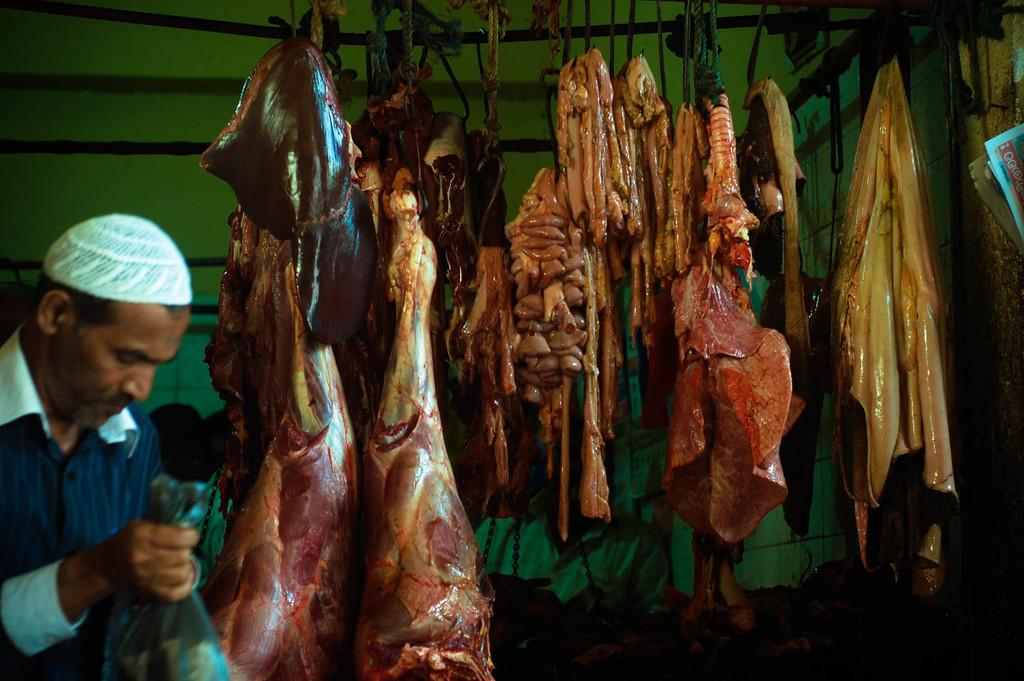What type of food is visible in the image? There is meat in the image. Can you describe the person in the image? There is a person in the bottom left of the image. What song is the person singing in the image? There is no indication in the image that the person is singing, so it cannot be determined from the picture. 